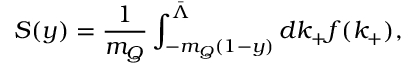<formula> <loc_0><loc_0><loc_500><loc_500>S ( y ) = \frac { 1 } { m _ { Q } } \int _ { - m _ { Q } ( 1 - y ) } ^ { \bar { \Lambda } } d k _ { + } f ( k _ { + } ) ,</formula> 